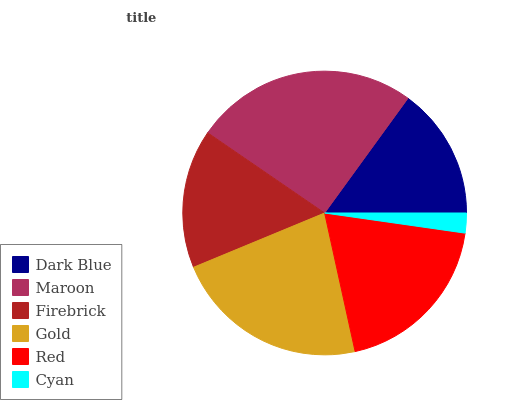Is Cyan the minimum?
Answer yes or no. Yes. Is Maroon the maximum?
Answer yes or no. Yes. Is Firebrick the minimum?
Answer yes or no. No. Is Firebrick the maximum?
Answer yes or no. No. Is Maroon greater than Firebrick?
Answer yes or no. Yes. Is Firebrick less than Maroon?
Answer yes or no. Yes. Is Firebrick greater than Maroon?
Answer yes or no. No. Is Maroon less than Firebrick?
Answer yes or no. No. Is Red the high median?
Answer yes or no. Yes. Is Firebrick the low median?
Answer yes or no. Yes. Is Maroon the high median?
Answer yes or no. No. Is Red the low median?
Answer yes or no. No. 